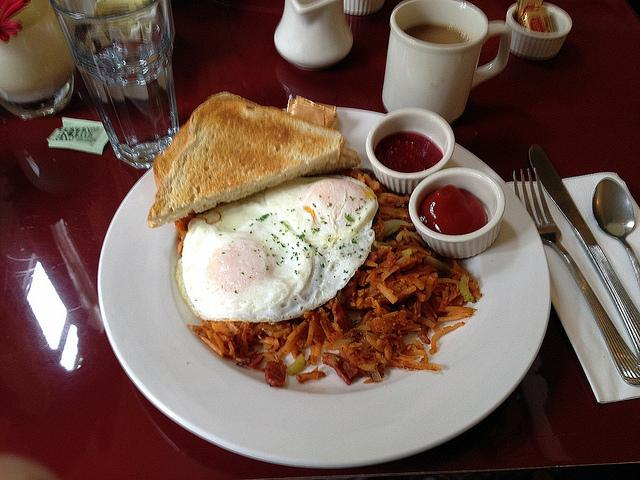What time of day is most likely? morning 